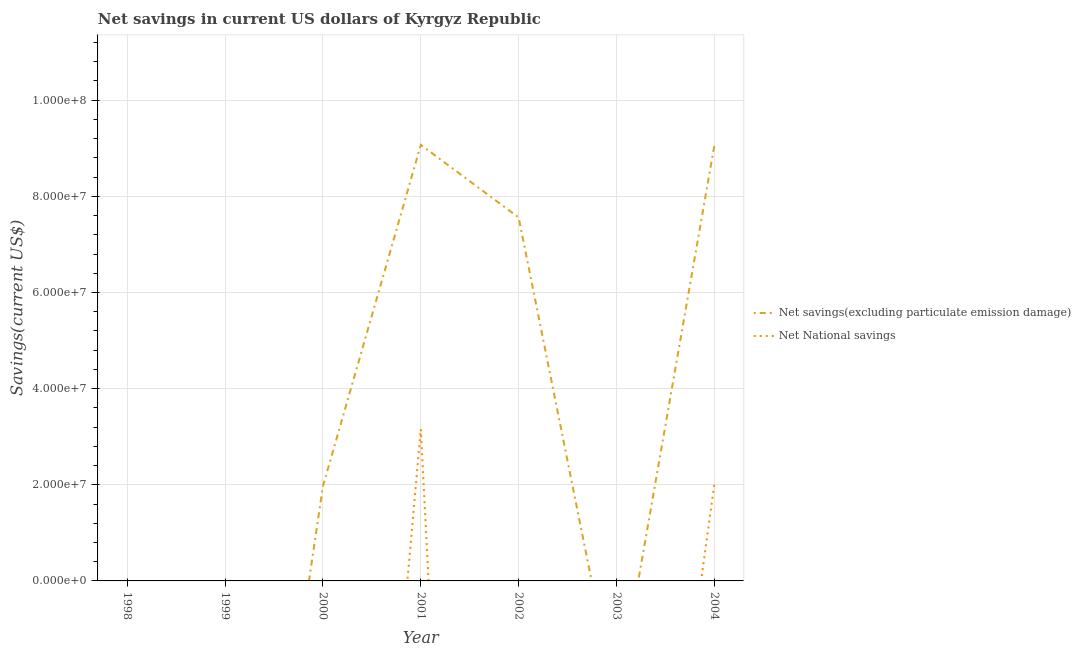How many different coloured lines are there?
Ensure brevity in your answer.  2. Is the number of lines equal to the number of legend labels?
Ensure brevity in your answer.  No. What is the net savings(excluding particulate emission damage) in 2002?
Provide a short and direct response. 7.56e+07. Across all years, what is the maximum net national savings?
Your answer should be compact. 3.15e+07. Across all years, what is the minimum net savings(excluding particulate emission damage)?
Keep it short and to the point. 0. In which year was the net national savings maximum?
Provide a succinct answer. 2001. What is the total net national savings in the graph?
Provide a short and direct response. 5.17e+07. What is the difference between the net savings(excluding particulate emission damage) in 2002 and that in 2004?
Your answer should be very brief. -1.50e+07. What is the difference between the net national savings in 2003 and the net savings(excluding particulate emission damage) in 1999?
Provide a succinct answer. 0. What is the average net national savings per year?
Your answer should be very brief. 7.39e+06. In the year 2004, what is the difference between the net national savings and net savings(excluding particulate emission damage)?
Ensure brevity in your answer.  -7.04e+07. What is the difference between the highest and the second highest net savings(excluding particulate emission damage)?
Give a very brief answer. 9.00e+04. What is the difference between the highest and the lowest net savings(excluding particulate emission damage)?
Your response must be concise. 9.07e+07. In how many years, is the net national savings greater than the average net national savings taken over all years?
Ensure brevity in your answer.  2. Does the net national savings monotonically increase over the years?
Your response must be concise. No. Is the net savings(excluding particulate emission damage) strictly greater than the net national savings over the years?
Your response must be concise. No. Is the net savings(excluding particulate emission damage) strictly less than the net national savings over the years?
Make the answer very short. No. How many years are there in the graph?
Offer a very short reply. 7. What is the difference between two consecutive major ticks on the Y-axis?
Provide a succinct answer. 2.00e+07. Does the graph contain any zero values?
Offer a very short reply. Yes. Does the graph contain grids?
Keep it short and to the point. Yes. Where does the legend appear in the graph?
Keep it short and to the point. Center right. How many legend labels are there?
Your response must be concise. 2. What is the title of the graph?
Ensure brevity in your answer.  Net savings in current US dollars of Kyrgyz Republic. What is the label or title of the X-axis?
Provide a short and direct response. Year. What is the label or title of the Y-axis?
Your answer should be compact. Savings(current US$). What is the Savings(current US$) of Net National savings in 1998?
Your answer should be very brief. 0. What is the Savings(current US$) in Net savings(excluding particulate emission damage) in 2000?
Your answer should be compact. 1.97e+07. What is the Savings(current US$) of Net National savings in 2000?
Give a very brief answer. 0. What is the Savings(current US$) in Net savings(excluding particulate emission damage) in 2001?
Your answer should be very brief. 9.07e+07. What is the Savings(current US$) of Net National savings in 2001?
Keep it short and to the point. 3.15e+07. What is the Savings(current US$) in Net savings(excluding particulate emission damage) in 2002?
Provide a succinct answer. 7.56e+07. What is the Savings(current US$) in Net National savings in 2003?
Your answer should be compact. 0. What is the Savings(current US$) of Net savings(excluding particulate emission damage) in 2004?
Keep it short and to the point. 9.06e+07. What is the Savings(current US$) of Net National savings in 2004?
Give a very brief answer. 2.02e+07. Across all years, what is the maximum Savings(current US$) in Net savings(excluding particulate emission damage)?
Your response must be concise. 9.07e+07. Across all years, what is the maximum Savings(current US$) in Net National savings?
Your answer should be compact. 3.15e+07. Across all years, what is the minimum Savings(current US$) of Net National savings?
Provide a short and direct response. 0. What is the total Savings(current US$) of Net savings(excluding particulate emission damage) in the graph?
Offer a very short reply. 2.77e+08. What is the total Savings(current US$) in Net National savings in the graph?
Ensure brevity in your answer.  5.17e+07. What is the difference between the Savings(current US$) of Net savings(excluding particulate emission damage) in 2000 and that in 2001?
Make the answer very short. -7.10e+07. What is the difference between the Savings(current US$) in Net savings(excluding particulate emission damage) in 2000 and that in 2002?
Your answer should be very brief. -5.59e+07. What is the difference between the Savings(current US$) of Net savings(excluding particulate emission damage) in 2000 and that in 2004?
Your answer should be very brief. -7.09e+07. What is the difference between the Savings(current US$) in Net savings(excluding particulate emission damage) in 2001 and that in 2002?
Offer a very short reply. 1.51e+07. What is the difference between the Savings(current US$) of Net savings(excluding particulate emission damage) in 2001 and that in 2004?
Provide a succinct answer. 9.00e+04. What is the difference between the Savings(current US$) of Net National savings in 2001 and that in 2004?
Ensure brevity in your answer.  1.14e+07. What is the difference between the Savings(current US$) of Net savings(excluding particulate emission damage) in 2002 and that in 2004?
Keep it short and to the point. -1.50e+07. What is the difference between the Savings(current US$) in Net savings(excluding particulate emission damage) in 2000 and the Savings(current US$) in Net National savings in 2001?
Offer a very short reply. -1.18e+07. What is the difference between the Savings(current US$) of Net savings(excluding particulate emission damage) in 2000 and the Savings(current US$) of Net National savings in 2004?
Give a very brief answer. -4.47e+05. What is the difference between the Savings(current US$) in Net savings(excluding particulate emission damage) in 2001 and the Savings(current US$) in Net National savings in 2004?
Provide a succinct answer. 7.05e+07. What is the difference between the Savings(current US$) of Net savings(excluding particulate emission damage) in 2002 and the Savings(current US$) of Net National savings in 2004?
Offer a very short reply. 5.54e+07. What is the average Savings(current US$) of Net savings(excluding particulate emission damage) per year?
Your answer should be compact. 3.95e+07. What is the average Savings(current US$) of Net National savings per year?
Provide a succinct answer. 7.39e+06. In the year 2001, what is the difference between the Savings(current US$) in Net savings(excluding particulate emission damage) and Savings(current US$) in Net National savings?
Provide a short and direct response. 5.92e+07. In the year 2004, what is the difference between the Savings(current US$) in Net savings(excluding particulate emission damage) and Savings(current US$) in Net National savings?
Provide a short and direct response. 7.04e+07. What is the ratio of the Savings(current US$) in Net savings(excluding particulate emission damage) in 2000 to that in 2001?
Give a very brief answer. 0.22. What is the ratio of the Savings(current US$) in Net savings(excluding particulate emission damage) in 2000 to that in 2002?
Your response must be concise. 0.26. What is the ratio of the Savings(current US$) of Net savings(excluding particulate emission damage) in 2000 to that in 2004?
Ensure brevity in your answer.  0.22. What is the ratio of the Savings(current US$) in Net savings(excluding particulate emission damage) in 2001 to that in 2002?
Give a very brief answer. 1.2. What is the ratio of the Savings(current US$) in Net National savings in 2001 to that in 2004?
Offer a terse response. 1.56. What is the ratio of the Savings(current US$) in Net savings(excluding particulate emission damage) in 2002 to that in 2004?
Give a very brief answer. 0.83. What is the difference between the highest and the second highest Savings(current US$) of Net savings(excluding particulate emission damage)?
Give a very brief answer. 9.00e+04. What is the difference between the highest and the lowest Savings(current US$) of Net savings(excluding particulate emission damage)?
Offer a terse response. 9.07e+07. What is the difference between the highest and the lowest Savings(current US$) in Net National savings?
Offer a terse response. 3.15e+07. 